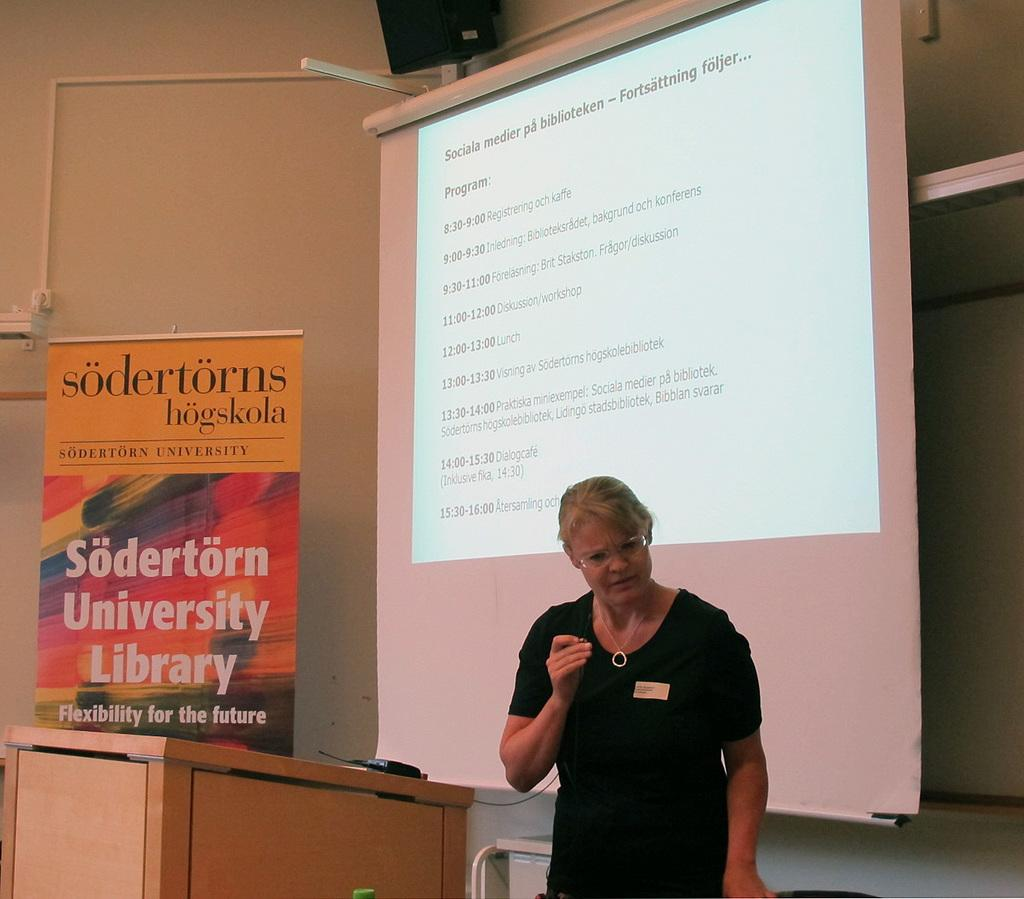Provide a one-sentence caption for the provided image. a woman standing by a sign that says sodertorn university library. 